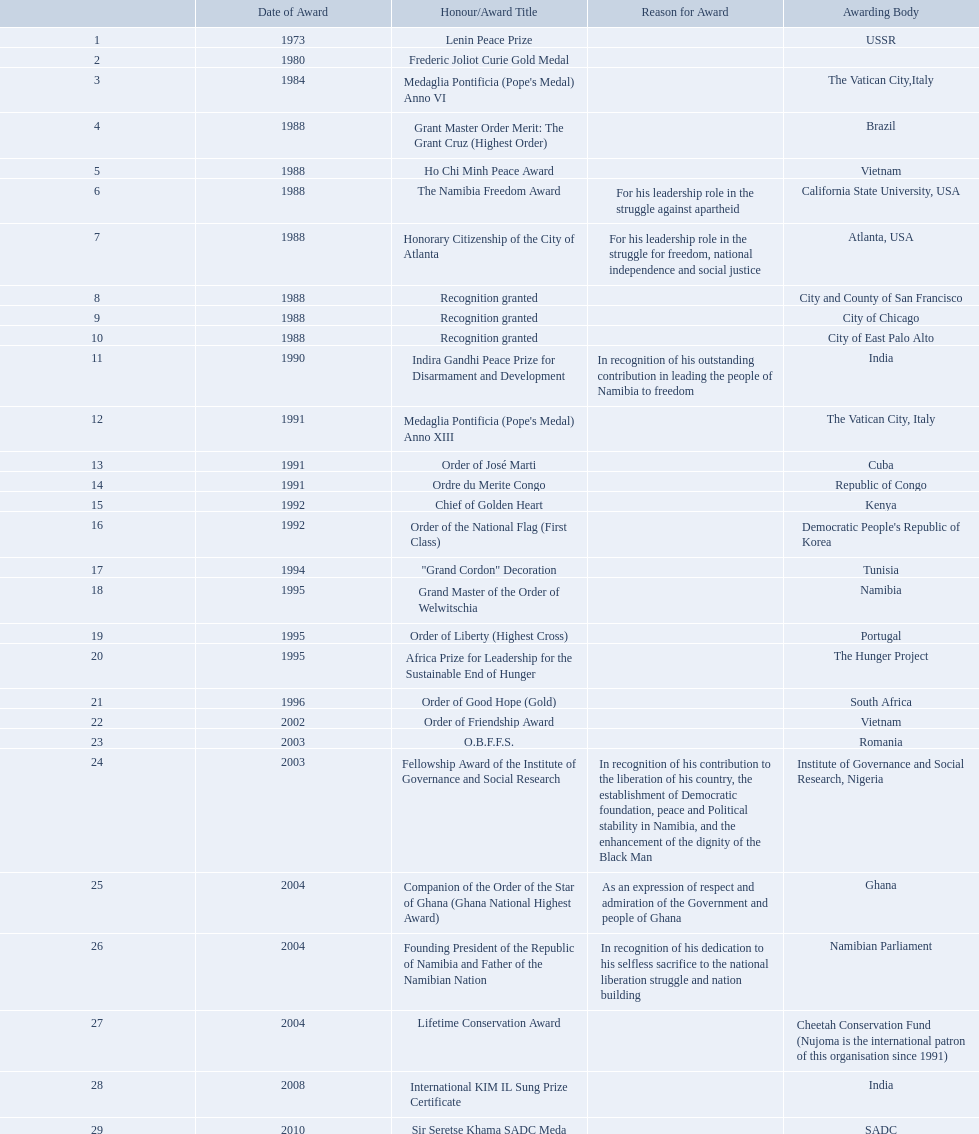What awards did sam nujoma win? 1, 1973, Lenin Peace Prize, Frederic Joliot Curie Gold Medal, Medaglia Pontificia (Pope's Medal) Anno VI, Grant Master Order Merit: The Grant Cruz (Highest Order), Ho Chi Minh Peace Award, The Namibia Freedom Award, Honorary Citizenship of the City of Atlanta, Recognition granted, Recognition granted, Recognition granted, Indira Gandhi Peace Prize for Disarmament and Development, Medaglia Pontificia (Pope's Medal) Anno XIII, Order of José Marti, Ordre du Merite Congo, Chief of Golden Heart, Order of the National Flag (First Class), "Grand Cordon" Decoration, Grand Master of the Order of Welwitschia, Order of Liberty (Highest Cross), Africa Prize for Leadership for the Sustainable End of Hunger, Order of Good Hope (Gold), Order of Friendship Award, O.B.F.F.S., Fellowship Award of the Institute of Governance and Social Research, Companion of the Order of the Star of Ghana (Ghana National Highest Award), Founding President of the Republic of Namibia and Father of the Namibian Nation, Lifetime Conservation Award, International KIM IL Sung Prize Certificate, Sir Seretse Khama SADC Meda. Who was the awarding body for the o.b.f.f.s award? Romania. What accolades were won by sam nujoma? 1, 1973, Lenin Peace Prize, Frederic Joliot Curie Gold Medal, Medaglia Pontificia (Pope's Medal) Anno VI, Grant Master Order Merit: The Grant Cruz (Highest Order), Ho Chi Minh Peace Award, The Namibia Freedom Award, Honorary Citizenship of the City of Atlanta, Recognition granted, Recognition granted, Recognition granted, Indira Gandhi Peace Prize for Disarmament and Development, Medaglia Pontificia (Pope's Medal) Anno XIII, Order of José Marti, Ordre du Merite Congo, Chief of Golden Heart, Order of the National Flag (First Class), "Grand Cordon" Decoration, Grand Master of the Order of Welwitschia, Order of Liberty (Highest Cross), Africa Prize for Leadership for the Sustainable End of Hunger, Order of Good Hope (Gold), Order of Friendship Award, O.B.F.F.S., Fellowship Award of the Institute of Governance and Social Research, Companion of the Order of the Star of Ghana (Ghana National Highest Award), Founding President of the Republic of Namibia and Father of the Namibian Nation, Lifetime Conservation Award, International KIM IL Sung Prize Certificate, Sir Seretse Khama SADC Meda. Who was responsible for giving the o.b.f.f.s. award? Romania. What recognitions were given to sam nujoma? 1, 1973, Lenin Peace Prize, Frederic Joliot Curie Gold Medal, Medaglia Pontificia (Pope's Medal) Anno VI, Grant Master Order Merit: The Grant Cruz (Highest Order), Ho Chi Minh Peace Award, The Namibia Freedom Award, Honorary Citizenship of the City of Atlanta, Recognition granted, Recognition granted, Recognition granted, Indira Gandhi Peace Prize for Disarmament and Development, Medaglia Pontificia (Pope's Medal) Anno XIII, Order of José Marti, Ordre du Merite Congo, Chief of Golden Heart, Order of the National Flag (First Class), "Grand Cordon" Decoration, Grand Master of the Order of Welwitschia, Order of Liberty (Highest Cross), Africa Prize for Leadership for the Sustainable End of Hunger, Order of Good Hope (Gold), Order of Friendship Award, O.B.F.F.S., Fellowship Award of the Institute of Governance and Social Research, Companion of the Order of the Star of Ghana (Ghana National Highest Award), Founding President of the Republic of Namibia and Father of the Namibian Nation, Lifetime Conservation Award, International KIM IL Sung Prize Certificate, Sir Seretse Khama SADC Meda. Who was responsible for giving out the obffs award? Romania. 